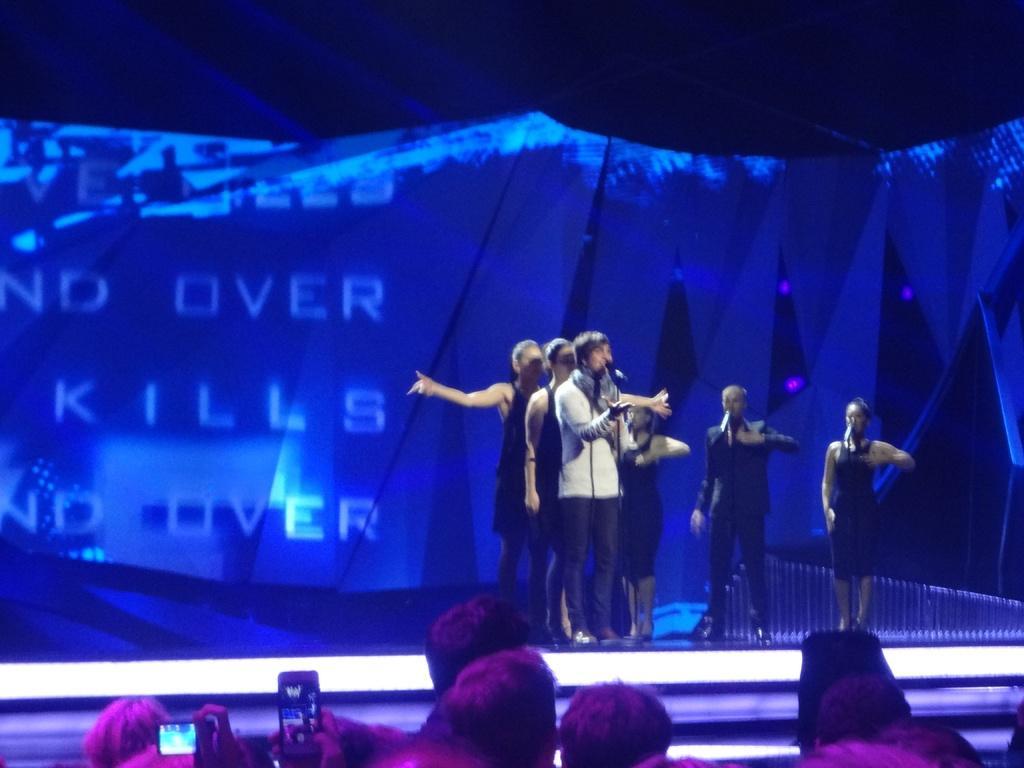Please provide a concise description of this image. In this image I can see the stage, few persons standing on the stage and few microphones in front of them. I can see few other persons standing in front of the stage and few of them are holding cell phones in their hands. In the background I can see a huge screen which is blue in color. 